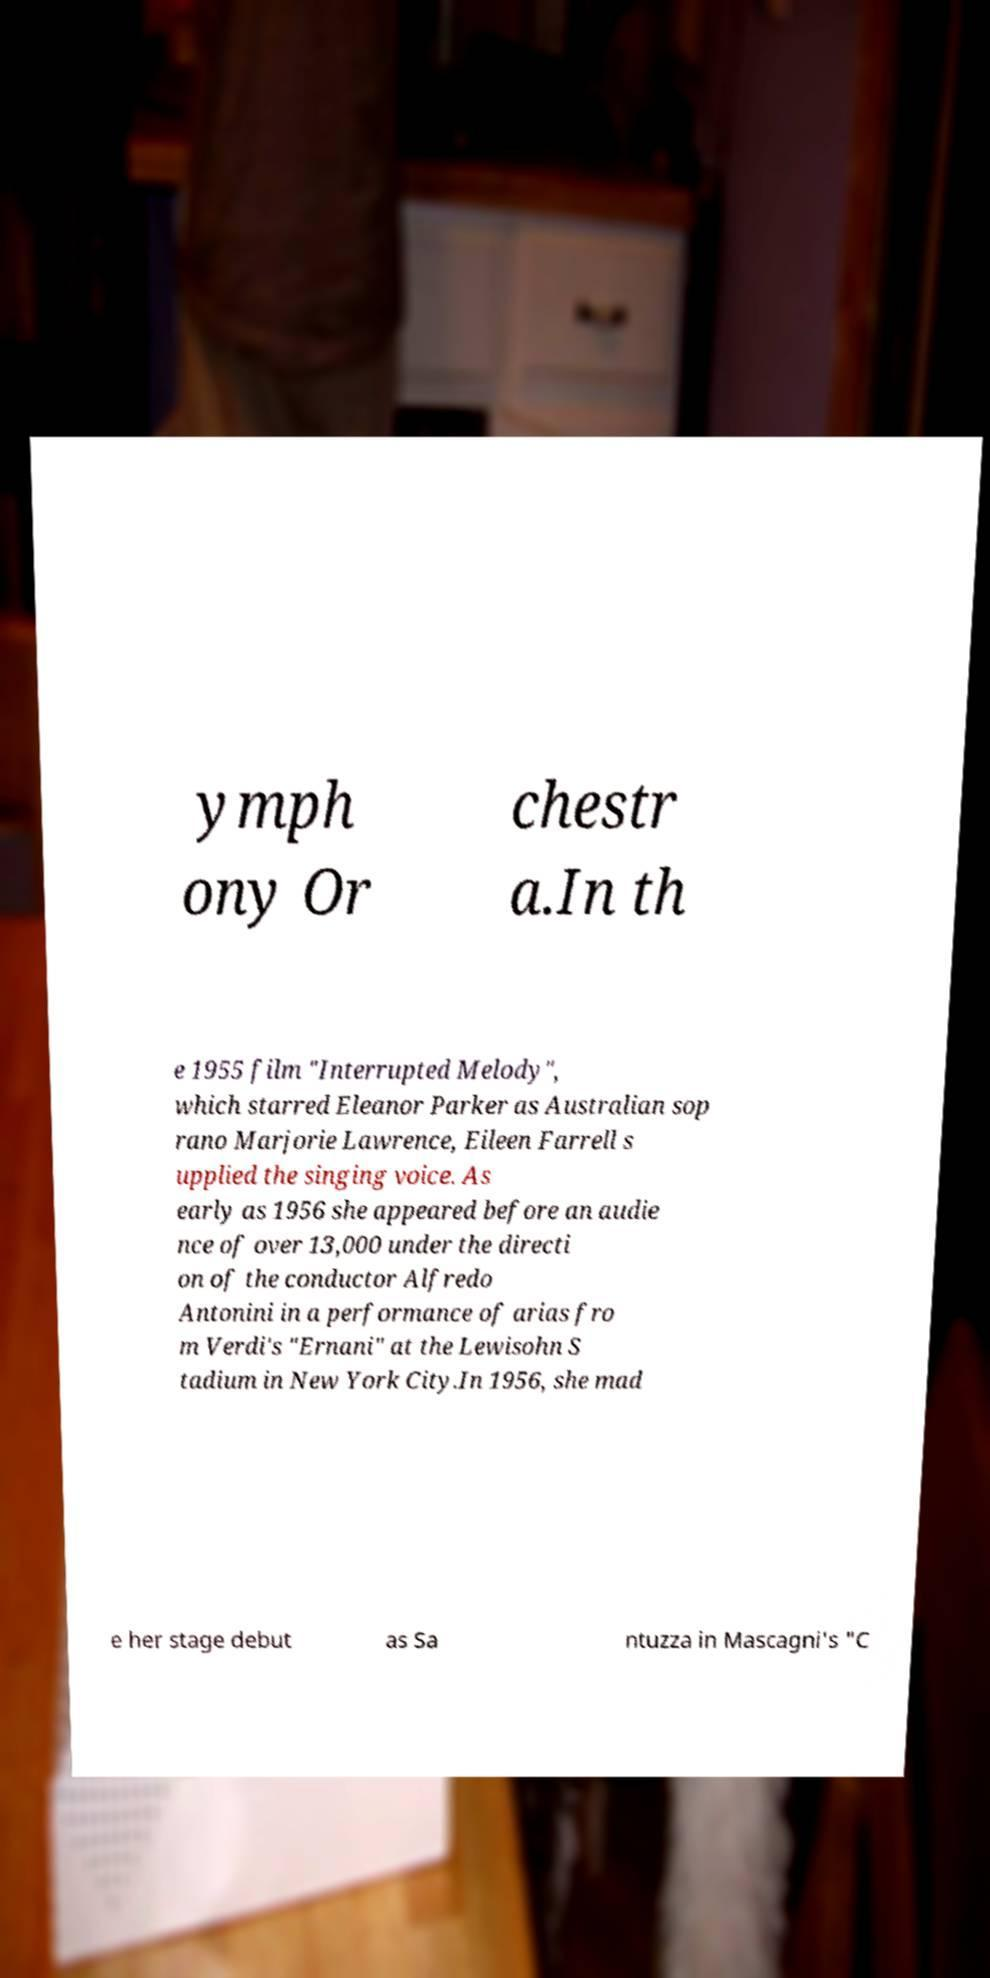Please identify and transcribe the text found in this image. ymph ony Or chestr a.In th e 1955 film "Interrupted Melody", which starred Eleanor Parker as Australian sop rano Marjorie Lawrence, Eileen Farrell s upplied the singing voice. As early as 1956 she appeared before an audie nce of over 13,000 under the directi on of the conductor Alfredo Antonini in a performance of arias fro m Verdi's "Ernani" at the Lewisohn S tadium in New York City.In 1956, she mad e her stage debut as Sa ntuzza in Mascagni's "C 